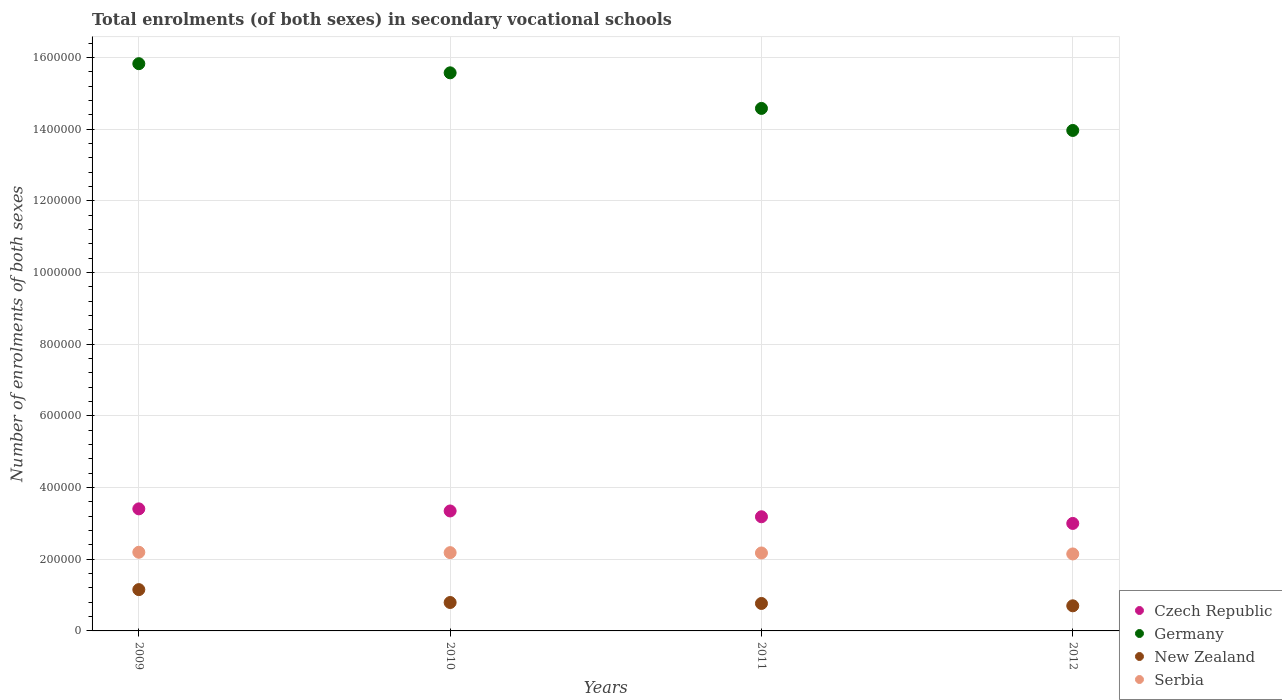How many different coloured dotlines are there?
Your response must be concise. 4. What is the number of enrolments in secondary schools in Czech Republic in 2010?
Your answer should be very brief. 3.35e+05. Across all years, what is the maximum number of enrolments in secondary schools in New Zealand?
Keep it short and to the point. 1.15e+05. Across all years, what is the minimum number of enrolments in secondary schools in Germany?
Offer a very short reply. 1.40e+06. In which year was the number of enrolments in secondary schools in Serbia minimum?
Ensure brevity in your answer.  2012. What is the total number of enrolments in secondary schools in Serbia in the graph?
Provide a short and direct response. 8.70e+05. What is the difference between the number of enrolments in secondary schools in New Zealand in 2009 and that in 2011?
Your answer should be very brief. 3.86e+04. What is the difference between the number of enrolments in secondary schools in Germany in 2011 and the number of enrolments in secondary schools in Czech Republic in 2012?
Make the answer very short. 1.16e+06. What is the average number of enrolments in secondary schools in New Zealand per year?
Offer a terse response. 8.53e+04. In the year 2009, what is the difference between the number of enrolments in secondary schools in Germany and number of enrolments in secondary schools in Czech Republic?
Make the answer very short. 1.24e+06. What is the ratio of the number of enrolments in secondary schools in New Zealand in 2009 to that in 2010?
Keep it short and to the point. 1.45. Is the difference between the number of enrolments in secondary schools in Germany in 2010 and 2011 greater than the difference between the number of enrolments in secondary schools in Czech Republic in 2010 and 2011?
Your answer should be very brief. Yes. What is the difference between the highest and the second highest number of enrolments in secondary schools in Czech Republic?
Your answer should be very brief. 5870. What is the difference between the highest and the lowest number of enrolments in secondary schools in Czech Republic?
Provide a succinct answer. 4.07e+04. Is it the case that in every year, the sum of the number of enrolments in secondary schools in Serbia and number of enrolments in secondary schools in Czech Republic  is greater than the sum of number of enrolments in secondary schools in New Zealand and number of enrolments in secondary schools in Germany?
Your answer should be compact. No. Is the number of enrolments in secondary schools in Serbia strictly greater than the number of enrolments in secondary schools in Czech Republic over the years?
Make the answer very short. No. How many dotlines are there?
Your answer should be compact. 4. How many years are there in the graph?
Provide a short and direct response. 4. Are the values on the major ticks of Y-axis written in scientific E-notation?
Give a very brief answer. No. Where does the legend appear in the graph?
Your answer should be very brief. Bottom right. What is the title of the graph?
Your answer should be very brief. Total enrolments (of both sexes) in secondary vocational schools. Does "Syrian Arab Republic" appear as one of the legend labels in the graph?
Provide a succinct answer. No. What is the label or title of the Y-axis?
Make the answer very short. Number of enrolments of both sexes. What is the Number of enrolments of both sexes of Czech Republic in 2009?
Offer a terse response. 3.41e+05. What is the Number of enrolments of both sexes of Germany in 2009?
Your answer should be very brief. 1.58e+06. What is the Number of enrolments of both sexes of New Zealand in 2009?
Provide a succinct answer. 1.15e+05. What is the Number of enrolments of both sexes of Serbia in 2009?
Your answer should be compact. 2.19e+05. What is the Number of enrolments of both sexes of Czech Republic in 2010?
Offer a very short reply. 3.35e+05. What is the Number of enrolments of both sexes of Germany in 2010?
Provide a short and direct response. 1.56e+06. What is the Number of enrolments of both sexes of New Zealand in 2010?
Offer a terse response. 7.93e+04. What is the Number of enrolments of both sexes in Serbia in 2010?
Provide a succinct answer. 2.18e+05. What is the Number of enrolments of both sexes in Czech Republic in 2011?
Ensure brevity in your answer.  3.19e+05. What is the Number of enrolments of both sexes of Germany in 2011?
Give a very brief answer. 1.46e+06. What is the Number of enrolments of both sexes in New Zealand in 2011?
Offer a very short reply. 7.66e+04. What is the Number of enrolments of both sexes in Serbia in 2011?
Provide a succinct answer. 2.17e+05. What is the Number of enrolments of both sexes in Czech Republic in 2012?
Your answer should be compact. 3.00e+05. What is the Number of enrolments of both sexes in Germany in 2012?
Ensure brevity in your answer.  1.40e+06. What is the Number of enrolments of both sexes of New Zealand in 2012?
Give a very brief answer. 7.01e+04. What is the Number of enrolments of both sexes of Serbia in 2012?
Offer a very short reply. 2.15e+05. Across all years, what is the maximum Number of enrolments of both sexes in Czech Republic?
Your answer should be very brief. 3.41e+05. Across all years, what is the maximum Number of enrolments of both sexes of Germany?
Provide a short and direct response. 1.58e+06. Across all years, what is the maximum Number of enrolments of both sexes in New Zealand?
Offer a very short reply. 1.15e+05. Across all years, what is the maximum Number of enrolments of both sexes in Serbia?
Give a very brief answer. 2.19e+05. Across all years, what is the minimum Number of enrolments of both sexes of Czech Republic?
Your answer should be compact. 3.00e+05. Across all years, what is the minimum Number of enrolments of both sexes of Germany?
Provide a succinct answer. 1.40e+06. Across all years, what is the minimum Number of enrolments of both sexes of New Zealand?
Your answer should be very brief. 7.01e+04. Across all years, what is the minimum Number of enrolments of both sexes in Serbia?
Give a very brief answer. 2.15e+05. What is the total Number of enrolments of both sexes of Czech Republic in the graph?
Ensure brevity in your answer.  1.29e+06. What is the total Number of enrolments of both sexes of Germany in the graph?
Your response must be concise. 5.99e+06. What is the total Number of enrolments of both sexes of New Zealand in the graph?
Your answer should be very brief. 3.41e+05. What is the total Number of enrolments of both sexes in Serbia in the graph?
Provide a succinct answer. 8.70e+05. What is the difference between the Number of enrolments of both sexes of Czech Republic in 2009 and that in 2010?
Make the answer very short. 5870. What is the difference between the Number of enrolments of both sexes in Germany in 2009 and that in 2010?
Make the answer very short. 2.55e+04. What is the difference between the Number of enrolments of both sexes in New Zealand in 2009 and that in 2010?
Your answer should be compact. 3.59e+04. What is the difference between the Number of enrolments of both sexes of Serbia in 2009 and that in 2010?
Make the answer very short. 1049. What is the difference between the Number of enrolments of both sexes of Czech Republic in 2009 and that in 2011?
Ensure brevity in your answer.  2.21e+04. What is the difference between the Number of enrolments of both sexes of Germany in 2009 and that in 2011?
Provide a succinct answer. 1.25e+05. What is the difference between the Number of enrolments of both sexes in New Zealand in 2009 and that in 2011?
Provide a succinct answer. 3.86e+04. What is the difference between the Number of enrolments of both sexes in Serbia in 2009 and that in 2011?
Provide a succinct answer. 1985. What is the difference between the Number of enrolments of both sexes in Czech Republic in 2009 and that in 2012?
Your response must be concise. 4.07e+04. What is the difference between the Number of enrolments of both sexes in Germany in 2009 and that in 2012?
Ensure brevity in your answer.  1.86e+05. What is the difference between the Number of enrolments of both sexes of New Zealand in 2009 and that in 2012?
Your answer should be compact. 4.52e+04. What is the difference between the Number of enrolments of both sexes in Serbia in 2009 and that in 2012?
Your answer should be compact. 4672. What is the difference between the Number of enrolments of both sexes in Czech Republic in 2010 and that in 2011?
Offer a terse response. 1.62e+04. What is the difference between the Number of enrolments of both sexes in Germany in 2010 and that in 2011?
Provide a succinct answer. 9.93e+04. What is the difference between the Number of enrolments of both sexes in New Zealand in 2010 and that in 2011?
Make the answer very short. 2677. What is the difference between the Number of enrolments of both sexes in Serbia in 2010 and that in 2011?
Your answer should be compact. 936. What is the difference between the Number of enrolments of both sexes in Czech Republic in 2010 and that in 2012?
Your answer should be very brief. 3.48e+04. What is the difference between the Number of enrolments of both sexes of Germany in 2010 and that in 2012?
Offer a very short reply. 1.61e+05. What is the difference between the Number of enrolments of both sexes of New Zealand in 2010 and that in 2012?
Your response must be concise. 9246. What is the difference between the Number of enrolments of both sexes of Serbia in 2010 and that in 2012?
Your answer should be very brief. 3623. What is the difference between the Number of enrolments of both sexes in Czech Republic in 2011 and that in 2012?
Keep it short and to the point. 1.86e+04. What is the difference between the Number of enrolments of both sexes in Germany in 2011 and that in 2012?
Offer a terse response. 6.15e+04. What is the difference between the Number of enrolments of both sexes in New Zealand in 2011 and that in 2012?
Offer a terse response. 6569. What is the difference between the Number of enrolments of both sexes in Serbia in 2011 and that in 2012?
Your response must be concise. 2687. What is the difference between the Number of enrolments of both sexes in Czech Republic in 2009 and the Number of enrolments of both sexes in Germany in 2010?
Give a very brief answer. -1.22e+06. What is the difference between the Number of enrolments of both sexes of Czech Republic in 2009 and the Number of enrolments of both sexes of New Zealand in 2010?
Your answer should be very brief. 2.61e+05. What is the difference between the Number of enrolments of both sexes of Czech Republic in 2009 and the Number of enrolments of both sexes of Serbia in 2010?
Offer a terse response. 1.22e+05. What is the difference between the Number of enrolments of both sexes of Germany in 2009 and the Number of enrolments of both sexes of New Zealand in 2010?
Offer a terse response. 1.50e+06. What is the difference between the Number of enrolments of both sexes in Germany in 2009 and the Number of enrolments of both sexes in Serbia in 2010?
Offer a terse response. 1.36e+06. What is the difference between the Number of enrolments of both sexes in New Zealand in 2009 and the Number of enrolments of both sexes in Serbia in 2010?
Provide a succinct answer. -1.03e+05. What is the difference between the Number of enrolments of both sexes in Czech Republic in 2009 and the Number of enrolments of both sexes in Germany in 2011?
Keep it short and to the point. -1.12e+06. What is the difference between the Number of enrolments of both sexes of Czech Republic in 2009 and the Number of enrolments of both sexes of New Zealand in 2011?
Offer a terse response. 2.64e+05. What is the difference between the Number of enrolments of both sexes in Czech Republic in 2009 and the Number of enrolments of both sexes in Serbia in 2011?
Your response must be concise. 1.23e+05. What is the difference between the Number of enrolments of both sexes of Germany in 2009 and the Number of enrolments of both sexes of New Zealand in 2011?
Make the answer very short. 1.51e+06. What is the difference between the Number of enrolments of both sexes of Germany in 2009 and the Number of enrolments of both sexes of Serbia in 2011?
Give a very brief answer. 1.37e+06. What is the difference between the Number of enrolments of both sexes of New Zealand in 2009 and the Number of enrolments of both sexes of Serbia in 2011?
Your answer should be very brief. -1.02e+05. What is the difference between the Number of enrolments of both sexes of Czech Republic in 2009 and the Number of enrolments of both sexes of Germany in 2012?
Provide a short and direct response. -1.06e+06. What is the difference between the Number of enrolments of both sexes of Czech Republic in 2009 and the Number of enrolments of both sexes of New Zealand in 2012?
Provide a short and direct response. 2.71e+05. What is the difference between the Number of enrolments of both sexes of Czech Republic in 2009 and the Number of enrolments of both sexes of Serbia in 2012?
Offer a terse response. 1.26e+05. What is the difference between the Number of enrolments of both sexes of Germany in 2009 and the Number of enrolments of both sexes of New Zealand in 2012?
Your answer should be very brief. 1.51e+06. What is the difference between the Number of enrolments of both sexes in Germany in 2009 and the Number of enrolments of both sexes in Serbia in 2012?
Keep it short and to the point. 1.37e+06. What is the difference between the Number of enrolments of both sexes of New Zealand in 2009 and the Number of enrolments of both sexes of Serbia in 2012?
Offer a terse response. -9.95e+04. What is the difference between the Number of enrolments of both sexes in Czech Republic in 2010 and the Number of enrolments of both sexes in Germany in 2011?
Give a very brief answer. -1.12e+06. What is the difference between the Number of enrolments of both sexes in Czech Republic in 2010 and the Number of enrolments of both sexes in New Zealand in 2011?
Your response must be concise. 2.58e+05. What is the difference between the Number of enrolments of both sexes in Czech Republic in 2010 and the Number of enrolments of both sexes in Serbia in 2011?
Provide a short and direct response. 1.17e+05. What is the difference between the Number of enrolments of both sexes in Germany in 2010 and the Number of enrolments of both sexes in New Zealand in 2011?
Provide a succinct answer. 1.48e+06. What is the difference between the Number of enrolments of both sexes of Germany in 2010 and the Number of enrolments of both sexes of Serbia in 2011?
Your response must be concise. 1.34e+06. What is the difference between the Number of enrolments of both sexes of New Zealand in 2010 and the Number of enrolments of both sexes of Serbia in 2011?
Your answer should be very brief. -1.38e+05. What is the difference between the Number of enrolments of both sexes in Czech Republic in 2010 and the Number of enrolments of both sexes in Germany in 2012?
Your answer should be compact. -1.06e+06. What is the difference between the Number of enrolments of both sexes in Czech Republic in 2010 and the Number of enrolments of both sexes in New Zealand in 2012?
Your answer should be very brief. 2.65e+05. What is the difference between the Number of enrolments of both sexes in Czech Republic in 2010 and the Number of enrolments of both sexes in Serbia in 2012?
Offer a very short reply. 1.20e+05. What is the difference between the Number of enrolments of both sexes in Germany in 2010 and the Number of enrolments of both sexes in New Zealand in 2012?
Your answer should be very brief. 1.49e+06. What is the difference between the Number of enrolments of both sexes of Germany in 2010 and the Number of enrolments of both sexes of Serbia in 2012?
Offer a terse response. 1.34e+06. What is the difference between the Number of enrolments of both sexes in New Zealand in 2010 and the Number of enrolments of both sexes in Serbia in 2012?
Keep it short and to the point. -1.35e+05. What is the difference between the Number of enrolments of both sexes in Czech Republic in 2011 and the Number of enrolments of both sexes in Germany in 2012?
Your response must be concise. -1.08e+06. What is the difference between the Number of enrolments of both sexes in Czech Republic in 2011 and the Number of enrolments of both sexes in New Zealand in 2012?
Your answer should be compact. 2.48e+05. What is the difference between the Number of enrolments of both sexes of Czech Republic in 2011 and the Number of enrolments of both sexes of Serbia in 2012?
Your answer should be very brief. 1.04e+05. What is the difference between the Number of enrolments of both sexes of Germany in 2011 and the Number of enrolments of both sexes of New Zealand in 2012?
Provide a succinct answer. 1.39e+06. What is the difference between the Number of enrolments of both sexes of Germany in 2011 and the Number of enrolments of both sexes of Serbia in 2012?
Your response must be concise. 1.24e+06. What is the difference between the Number of enrolments of both sexes of New Zealand in 2011 and the Number of enrolments of both sexes of Serbia in 2012?
Keep it short and to the point. -1.38e+05. What is the average Number of enrolments of both sexes of Czech Republic per year?
Provide a short and direct response. 3.23e+05. What is the average Number of enrolments of both sexes in Germany per year?
Offer a very short reply. 1.50e+06. What is the average Number of enrolments of both sexes of New Zealand per year?
Offer a very short reply. 8.53e+04. What is the average Number of enrolments of both sexes of Serbia per year?
Make the answer very short. 2.18e+05. In the year 2009, what is the difference between the Number of enrolments of both sexes of Czech Republic and Number of enrolments of both sexes of Germany?
Offer a very short reply. -1.24e+06. In the year 2009, what is the difference between the Number of enrolments of both sexes in Czech Republic and Number of enrolments of both sexes in New Zealand?
Offer a terse response. 2.25e+05. In the year 2009, what is the difference between the Number of enrolments of both sexes in Czech Republic and Number of enrolments of both sexes in Serbia?
Provide a short and direct response. 1.21e+05. In the year 2009, what is the difference between the Number of enrolments of both sexes of Germany and Number of enrolments of both sexes of New Zealand?
Keep it short and to the point. 1.47e+06. In the year 2009, what is the difference between the Number of enrolments of both sexes in Germany and Number of enrolments of both sexes in Serbia?
Your answer should be very brief. 1.36e+06. In the year 2009, what is the difference between the Number of enrolments of both sexes of New Zealand and Number of enrolments of both sexes of Serbia?
Offer a terse response. -1.04e+05. In the year 2010, what is the difference between the Number of enrolments of both sexes in Czech Republic and Number of enrolments of both sexes in Germany?
Provide a succinct answer. -1.22e+06. In the year 2010, what is the difference between the Number of enrolments of both sexes of Czech Republic and Number of enrolments of both sexes of New Zealand?
Make the answer very short. 2.55e+05. In the year 2010, what is the difference between the Number of enrolments of both sexes in Czech Republic and Number of enrolments of both sexes in Serbia?
Your answer should be compact. 1.16e+05. In the year 2010, what is the difference between the Number of enrolments of both sexes of Germany and Number of enrolments of both sexes of New Zealand?
Your response must be concise. 1.48e+06. In the year 2010, what is the difference between the Number of enrolments of both sexes of Germany and Number of enrolments of both sexes of Serbia?
Offer a very short reply. 1.34e+06. In the year 2010, what is the difference between the Number of enrolments of both sexes of New Zealand and Number of enrolments of both sexes of Serbia?
Your response must be concise. -1.39e+05. In the year 2011, what is the difference between the Number of enrolments of both sexes in Czech Republic and Number of enrolments of both sexes in Germany?
Keep it short and to the point. -1.14e+06. In the year 2011, what is the difference between the Number of enrolments of both sexes of Czech Republic and Number of enrolments of both sexes of New Zealand?
Give a very brief answer. 2.42e+05. In the year 2011, what is the difference between the Number of enrolments of both sexes in Czech Republic and Number of enrolments of both sexes in Serbia?
Your answer should be very brief. 1.01e+05. In the year 2011, what is the difference between the Number of enrolments of both sexes in Germany and Number of enrolments of both sexes in New Zealand?
Provide a short and direct response. 1.38e+06. In the year 2011, what is the difference between the Number of enrolments of both sexes of Germany and Number of enrolments of both sexes of Serbia?
Give a very brief answer. 1.24e+06. In the year 2011, what is the difference between the Number of enrolments of both sexes in New Zealand and Number of enrolments of both sexes in Serbia?
Ensure brevity in your answer.  -1.41e+05. In the year 2012, what is the difference between the Number of enrolments of both sexes of Czech Republic and Number of enrolments of both sexes of Germany?
Provide a short and direct response. -1.10e+06. In the year 2012, what is the difference between the Number of enrolments of both sexes in Czech Republic and Number of enrolments of both sexes in New Zealand?
Make the answer very short. 2.30e+05. In the year 2012, what is the difference between the Number of enrolments of both sexes in Czech Republic and Number of enrolments of both sexes in Serbia?
Your response must be concise. 8.51e+04. In the year 2012, what is the difference between the Number of enrolments of both sexes of Germany and Number of enrolments of both sexes of New Zealand?
Your response must be concise. 1.33e+06. In the year 2012, what is the difference between the Number of enrolments of both sexes of Germany and Number of enrolments of both sexes of Serbia?
Provide a succinct answer. 1.18e+06. In the year 2012, what is the difference between the Number of enrolments of both sexes of New Zealand and Number of enrolments of both sexes of Serbia?
Your response must be concise. -1.45e+05. What is the ratio of the Number of enrolments of both sexes in Czech Republic in 2009 to that in 2010?
Offer a very short reply. 1.02. What is the ratio of the Number of enrolments of both sexes of Germany in 2009 to that in 2010?
Offer a very short reply. 1.02. What is the ratio of the Number of enrolments of both sexes in New Zealand in 2009 to that in 2010?
Offer a terse response. 1.45. What is the ratio of the Number of enrolments of both sexes in Czech Republic in 2009 to that in 2011?
Ensure brevity in your answer.  1.07. What is the ratio of the Number of enrolments of both sexes of Germany in 2009 to that in 2011?
Make the answer very short. 1.09. What is the ratio of the Number of enrolments of both sexes of New Zealand in 2009 to that in 2011?
Ensure brevity in your answer.  1.5. What is the ratio of the Number of enrolments of both sexes in Serbia in 2009 to that in 2011?
Make the answer very short. 1.01. What is the ratio of the Number of enrolments of both sexes in Czech Republic in 2009 to that in 2012?
Provide a succinct answer. 1.14. What is the ratio of the Number of enrolments of both sexes of Germany in 2009 to that in 2012?
Ensure brevity in your answer.  1.13. What is the ratio of the Number of enrolments of both sexes of New Zealand in 2009 to that in 2012?
Provide a succinct answer. 1.65. What is the ratio of the Number of enrolments of both sexes of Serbia in 2009 to that in 2012?
Your response must be concise. 1.02. What is the ratio of the Number of enrolments of both sexes of Czech Republic in 2010 to that in 2011?
Your response must be concise. 1.05. What is the ratio of the Number of enrolments of both sexes in Germany in 2010 to that in 2011?
Offer a very short reply. 1.07. What is the ratio of the Number of enrolments of both sexes of New Zealand in 2010 to that in 2011?
Your response must be concise. 1.03. What is the ratio of the Number of enrolments of both sexes of Czech Republic in 2010 to that in 2012?
Your response must be concise. 1.12. What is the ratio of the Number of enrolments of both sexes in Germany in 2010 to that in 2012?
Provide a short and direct response. 1.12. What is the ratio of the Number of enrolments of both sexes in New Zealand in 2010 to that in 2012?
Your answer should be compact. 1.13. What is the ratio of the Number of enrolments of both sexes in Serbia in 2010 to that in 2012?
Provide a short and direct response. 1.02. What is the ratio of the Number of enrolments of both sexes of Czech Republic in 2011 to that in 2012?
Give a very brief answer. 1.06. What is the ratio of the Number of enrolments of both sexes of Germany in 2011 to that in 2012?
Offer a terse response. 1.04. What is the ratio of the Number of enrolments of both sexes in New Zealand in 2011 to that in 2012?
Provide a succinct answer. 1.09. What is the ratio of the Number of enrolments of both sexes of Serbia in 2011 to that in 2012?
Provide a short and direct response. 1.01. What is the difference between the highest and the second highest Number of enrolments of both sexes in Czech Republic?
Ensure brevity in your answer.  5870. What is the difference between the highest and the second highest Number of enrolments of both sexes in Germany?
Offer a terse response. 2.55e+04. What is the difference between the highest and the second highest Number of enrolments of both sexes of New Zealand?
Ensure brevity in your answer.  3.59e+04. What is the difference between the highest and the second highest Number of enrolments of both sexes in Serbia?
Your answer should be very brief. 1049. What is the difference between the highest and the lowest Number of enrolments of both sexes of Czech Republic?
Provide a short and direct response. 4.07e+04. What is the difference between the highest and the lowest Number of enrolments of both sexes of Germany?
Your answer should be compact. 1.86e+05. What is the difference between the highest and the lowest Number of enrolments of both sexes of New Zealand?
Provide a short and direct response. 4.52e+04. What is the difference between the highest and the lowest Number of enrolments of both sexes of Serbia?
Make the answer very short. 4672. 